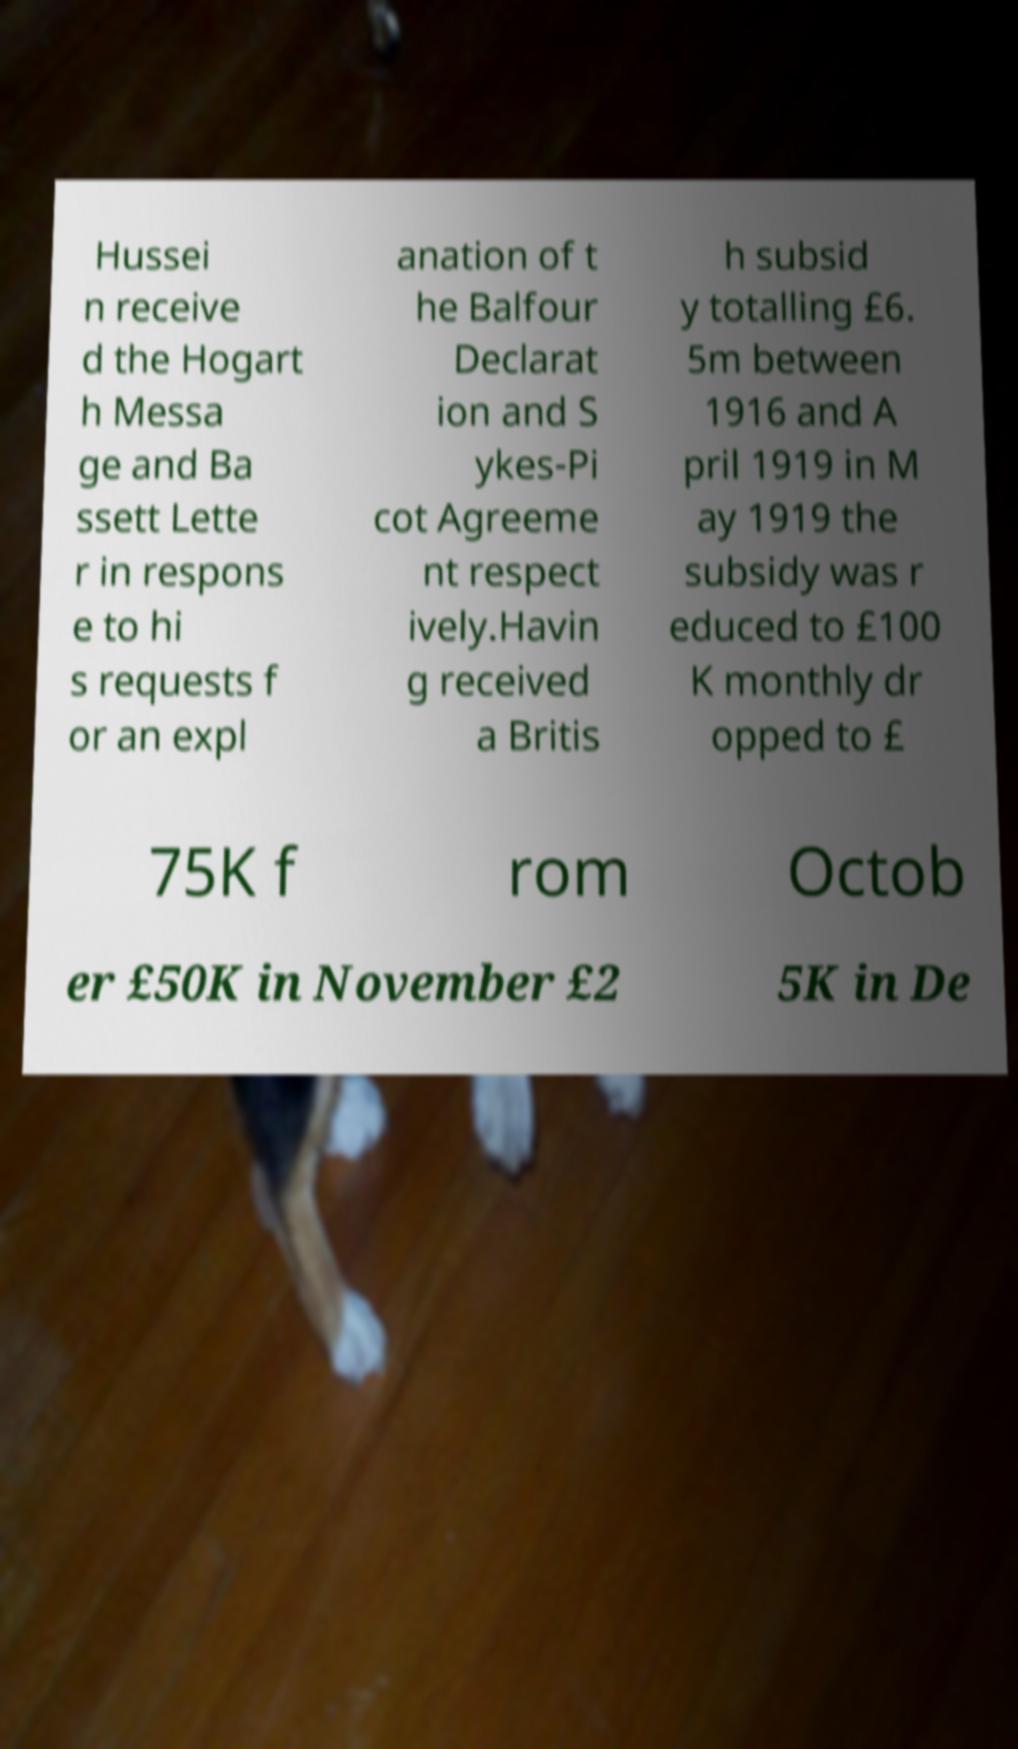Can you read and provide the text displayed in the image?This photo seems to have some interesting text. Can you extract and type it out for me? Hussei n receive d the Hogart h Messa ge and Ba ssett Lette r in respons e to hi s requests f or an expl anation of t he Balfour Declarat ion and S ykes-Pi cot Agreeme nt respect ively.Havin g received a Britis h subsid y totalling £6. 5m between 1916 and A pril 1919 in M ay 1919 the subsidy was r educed to £100 K monthly dr opped to £ 75K f rom Octob er £50K in November £2 5K in De 